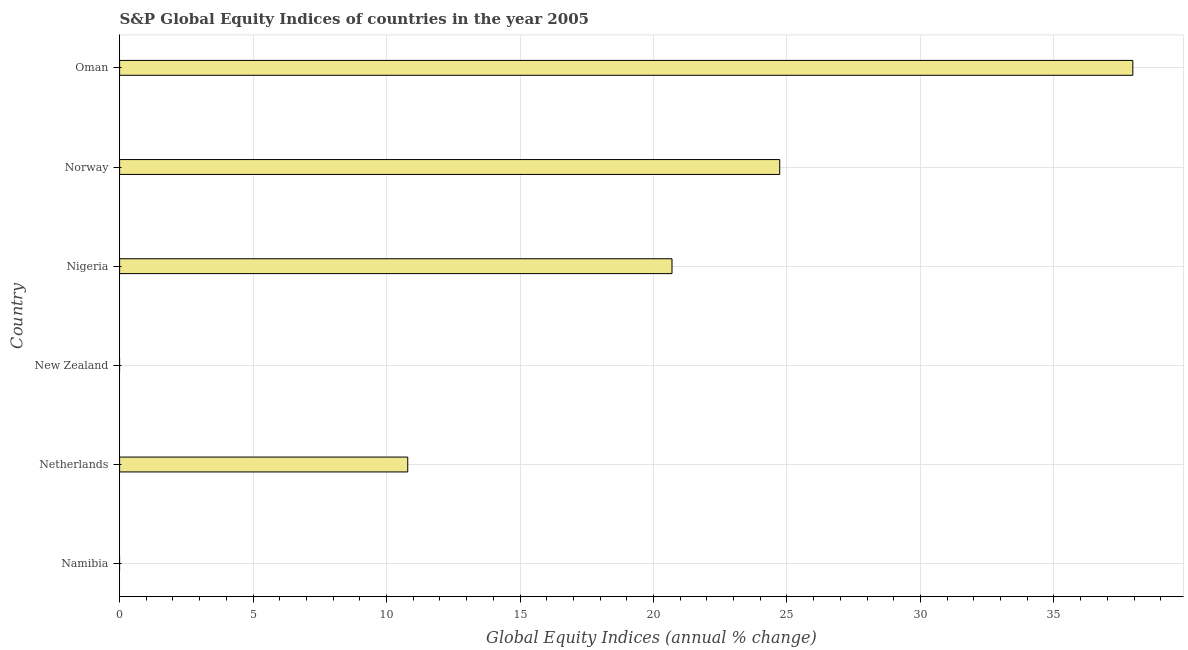Does the graph contain any zero values?
Make the answer very short. Yes. What is the title of the graph?
Provide a short and direct response. S&P Global Equity Indices of countries in the year 2005. What is the label or title of the X-axis?
Provide a succinct answer. Global Equity Indices (annual % change). What is the s&p global equity indices in Namibia?
Make the answer very short. 0. Across all countries, what is the maximum s&p global equity indices?
Make the answer very short. 37.96. Across all countries, what is the minimum s&p global equity indices?
Keep it short and to the point. 0. In which country was the s&p global equity indices maximum?
Offer a very short reply. Oman. What is the sum of the s&p global equity indices?
Your answer should be compact. 94.17. What is the difference between the s&p global equity indices in Netherlands and Oman?
Provide a succinct answer. -27.16. What is the average s&p global equity indices per country?
Your response must be concise. 15.7. What is the median s&p global equity indices?
Provide a succinct answer. 15.74. What is the ratio of the s&p global equity indices in Nigeria to that in Norway?
Offer a very short reply. 0.84. Is the s&p global equity indices in Nigeria less than that in Oman?
Ensure brevity in your answer.  Yes. Is the difference between the s&p global equity indices in Nigeria and Norway greater than the difference between any two countries?
Offer a terse response. No. What is the difference between the highest and the second highest s&p global equity indices?
Offer a very short reply. 13.23. What is the difference between the highest and the lowest s&p global equity indices?
Your answer should be very brief. 37.96. In how many countries, is the s&p global equity indices greater than the average s&p global equity indices taken over all countries?
Make the answer very short. 3. What is the Global Equity Indices (annual % change) of Namibia?
Your answer should be compact. 0. What is the Global Equity Indices (annual % change) in Netherlands?
Provide a short and direct response. 10.79. What is the Global Equity Indices (annual % change) of Nigeria?
Offer a terse response. 20.69. What is the Global Equity Indices (annual % change) in Norway?
Your answer should be compact. 24.73. What is the Global Equity Indices (annual % change) of Oman?
Provide a succinct answer. 37.96. What is the difference between the Global Equity Indices (annual % change) in Netherlands and Nigeria?
Ensure brevity in your answer.  -9.9. What is the difference between the Global Equity Indices (annual % change) in Netherlands and Norway?
Your response must be concise. -13.93. What is the difference between the Global Equity Indices (annual % change) in Netherlands and Oman?
Provide a short and direct response. -27.16. What is the difference between the Global Equity Indices (annual % change) in Nigeria and Norway?
Offer a terse response. -4.04. What is the difference between the Global Equity Indices (annual % change) in Nigeria and Oman?
Provide a succinct answer. -17.26. What is the difference between the Global Equity Indices (annual % change) in Norway and Oman?
Offer a terse response. -13.23. What is the ratio of the Global Equity Indices (annual % change) in Netherlands to that in Nigeria?
Provide a succinct answer. 0.52. What is the ratio of the Global Equity Indices (annual % change) in Netherlands to that in Norway?
Give a very brief answer. 0.44. What is the ratio of the Global Equity Indices (annual % change) in Netherlands to that in Oman?
Make the answer very short. 0.28. What is the ratio of the Global Equity Indices (annual % change) in Nigeria to that in Norway?
Your answer should be compact. 0.84. What is the ratio of the Global Equity Indices (annual % change) in Nigeria to that in Oman?
Provide a succinct answer. 0.55. What is the ratio of the Global Equity Indices (annual % change) in Norway to that in Oman?
Provide a short and direct response. 0.65. 